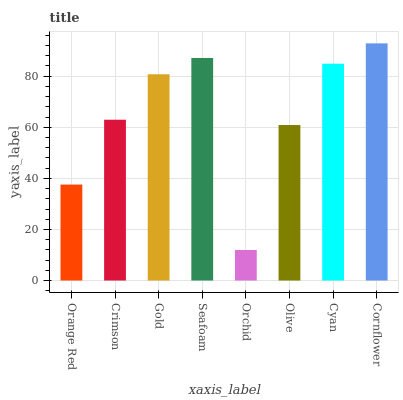Is Orchid the minimum?
Answer yes or no. Yes. Is Cornflower the maximum?
Answer yes or no. Yes. Is Crimson the minimum?
Answer yes or no. No. Is Crimson the maximum?
Answer yes or no. No. Is Crimson greater than Orange Red?
Answer yes or no. Yes. Is Orange Red less than Crimson?
Answer yes or no. Yes. Is Orange Red greater than Crimson?
Answer yes or no. No. Is Crimson less than Orange Red?
Answer yes or no. No. Is Gold the high median?
Answer yes or no. Yes. Is Crimson the low median?
Answer yes or no. Yes. Is Cyan the high median?
Answer yes or no. No. Is Cyan the low median?
Answer yes or no. No. 